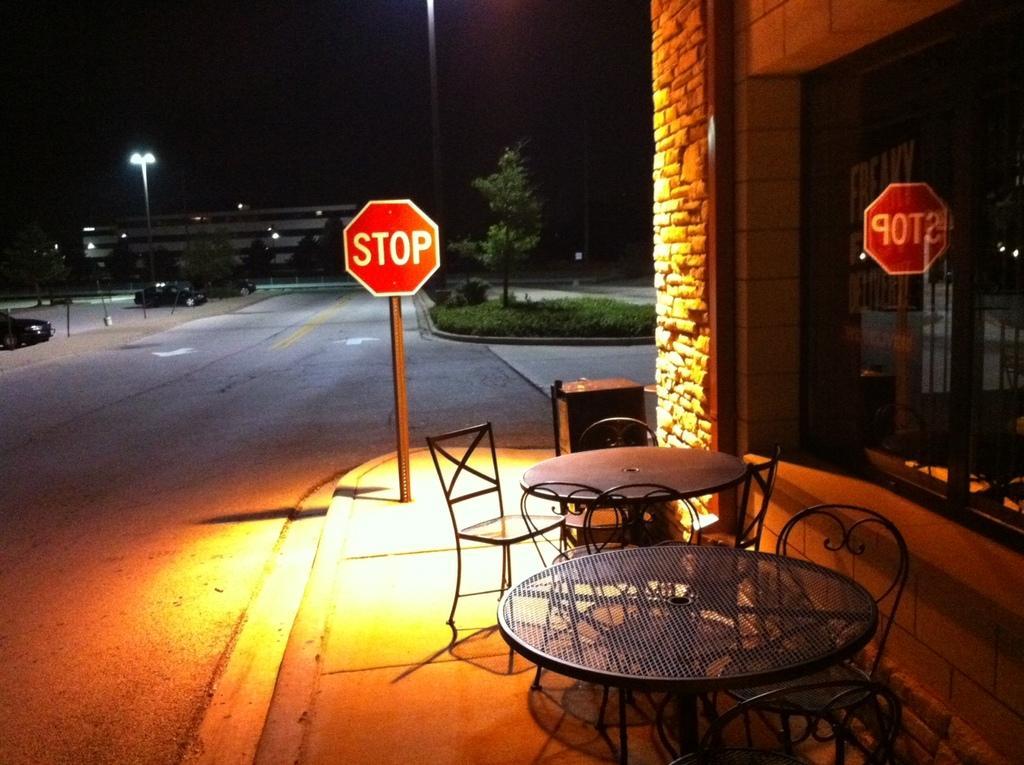Describe this image in one or two sentences. Picture consists of sky, street light, building, stop board, patio, table, chairs and one car. 